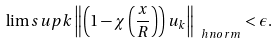Convert formula to latex. <formula><loc_0><loc_0><loc_500><loc_500>\lim s u p k \left \| \left ( 1 - \chi \left ( \frac { x } { R } \right ) \right ) u _ { k } \right \| _ { \ h n o r m } < \epsilon .</formula> 